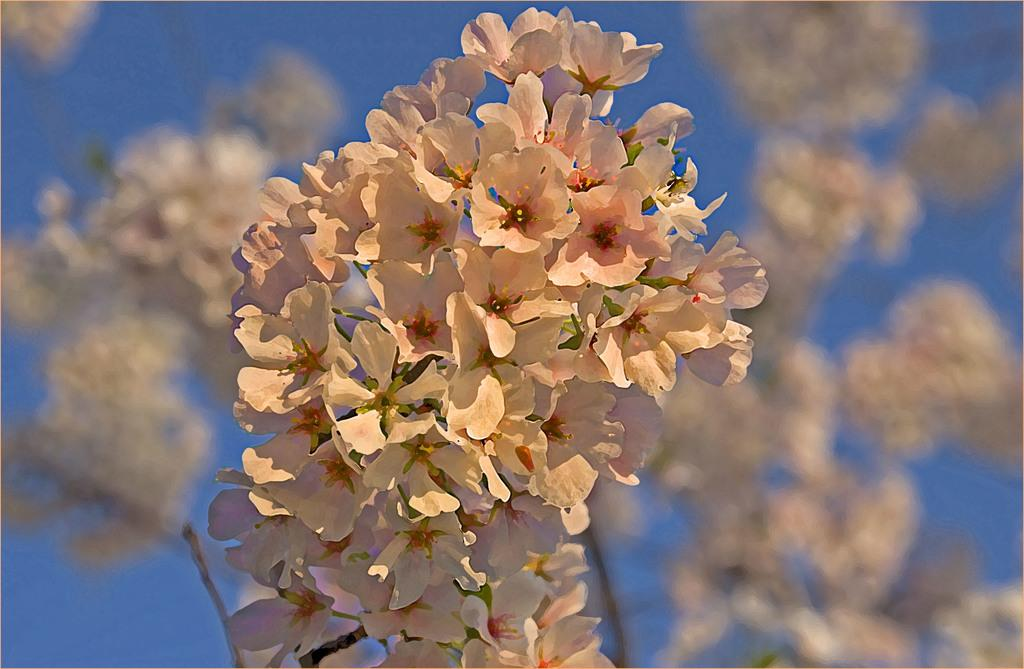What is present in the foreground of the image? There are flowers in the foreground of the image. What is present in the background of the image? There are flowers and the sky visible in the background of the image. What type of fruit is hanging from the flowers in the image? There is no fruit present in the image; it features flowers in both the foreground and background. 